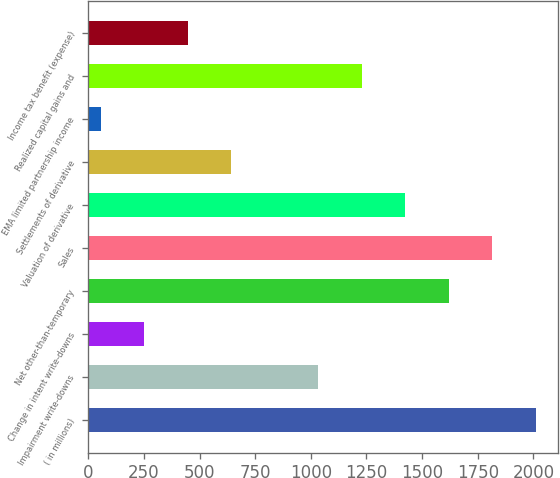<chart> <loc_0><loc_0><loc_500><loc_500><bar_chart><fcel>( in millions)<fcel>Impairment write-downs<fcel>Change in intent write-downs<fcel>Net other-than-temporary<fcel>Sales<fcel>Valuation of derivative<fcel>Settlements of derivative<fcel>EMA limited partnership income<fcel>Realized capital gains and<fcel>Income tax benefit (expense)<nl><fcel>2010<fcel>1032.5<fcel>250.5<fcel>1619<fcel>1814.5<fcel>1423.5<fcel>641.5<fcel>55<fcel>1228<fcel>446<nl></chart> 